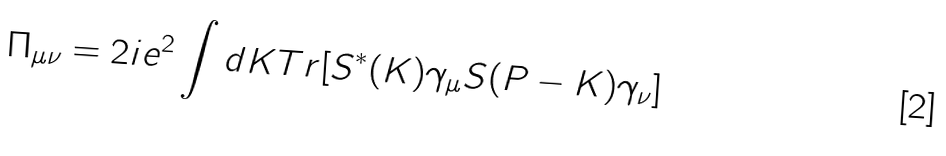<formula> <loc_0><loc_0><loc_500><loc_500>\Pi _ { \mu \nu } = 2 i e ^ { 2 } \int d K T r [ S ^ { * } ( K ) \gamma _ { \mu } S ( P - K ) \gamma _ { \nu } ]</formula> 